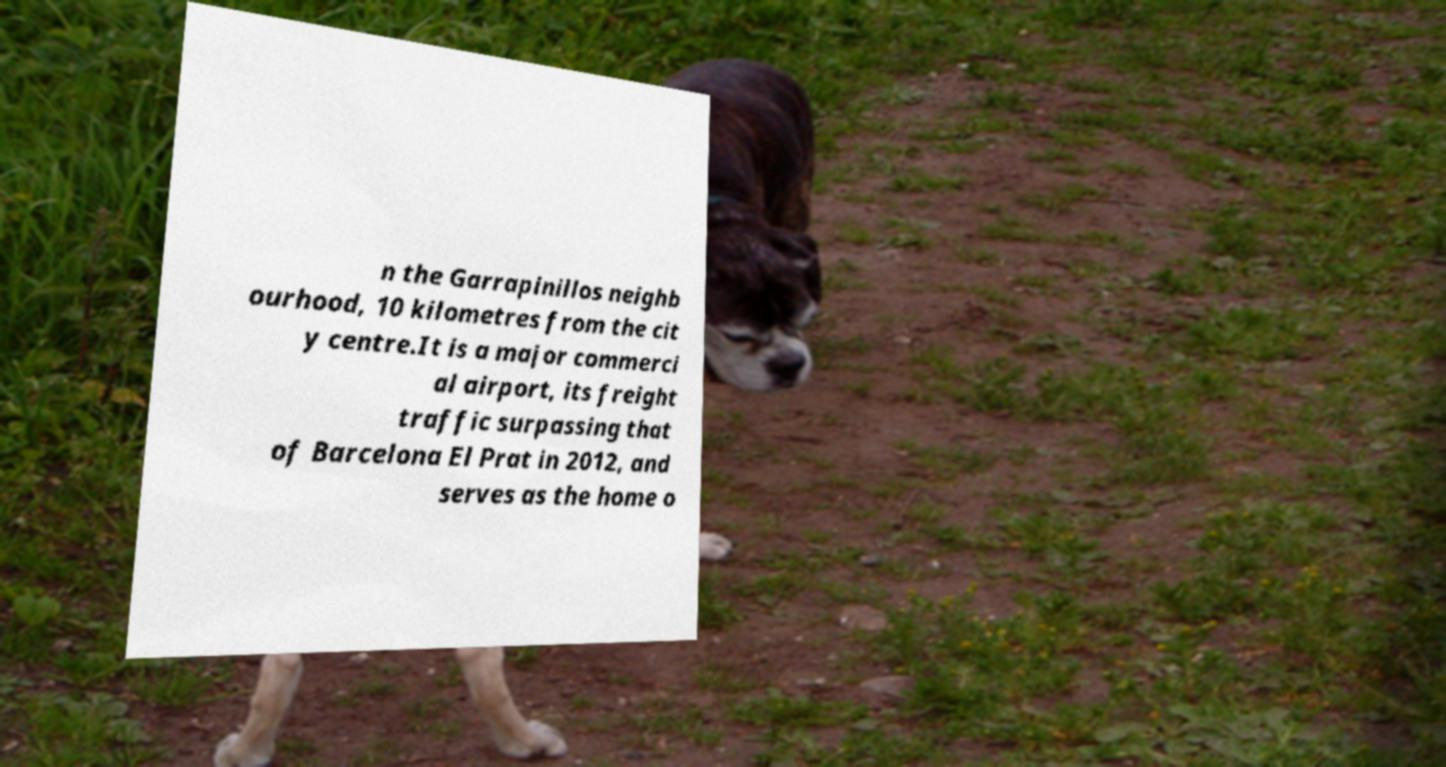Please identify and transcribe the text found in this image. n the Garrapinillos neighb ourhood, 10 kilometres from the cit y centre.It is a major commerci al airport, its freight traffic surpassing that of Barcelona El Prat in 2012, and serves as the home o 